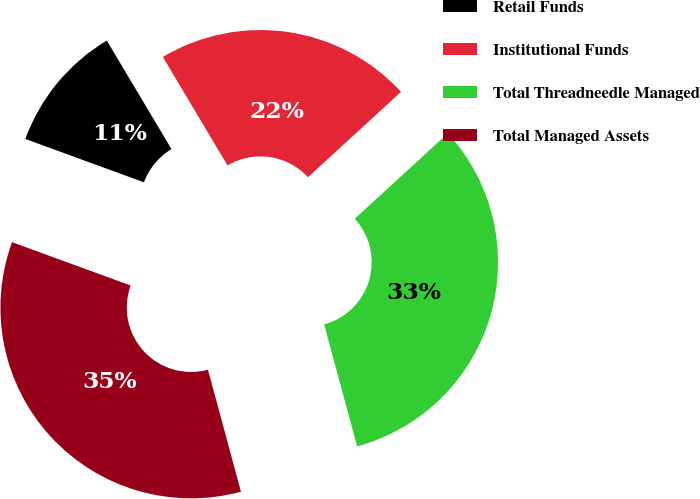Convert chart to OTSL. <chart><loc_0><loc_0><loc_500><loc_500><pie_chart><fcel>Retail Funds<fcel>Institutional Funds<fcel>Total Threadneedle Managed<fcel>Total Managed Assets<nl><fcel>10.87%<fcel>21.74%<fcel>32.61%<fcel>34.78%<nl></chart> 